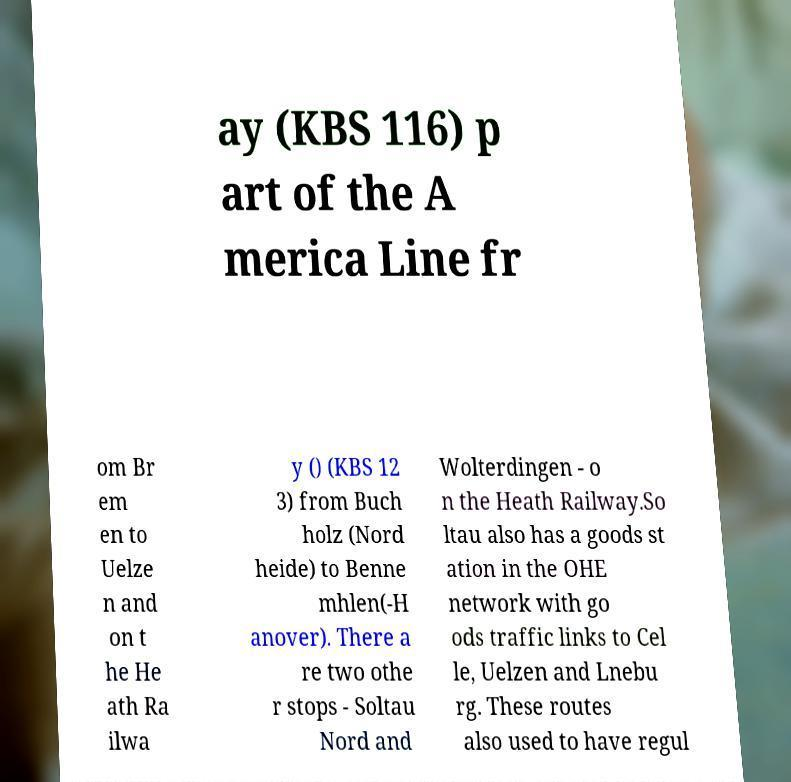Could you assist in decoding the text presented in this image and type it out clearly? ay (KBS 116) p art of the A merica Line fr om Br em en to Uelze n and on t he He ath Ra ilwa y () (KBS 12 3) from Buch holz (Nord heide) to Benne mhlen(-H anover). There a re two othe r stops - Soltau Nord and Wolterdingen - o n the Heath Railway.So ltau also has a goods st ation in the OHE network with go ods traffic links to Cel le, Uelzen and Lnebu rg. These routes also used to have regul 